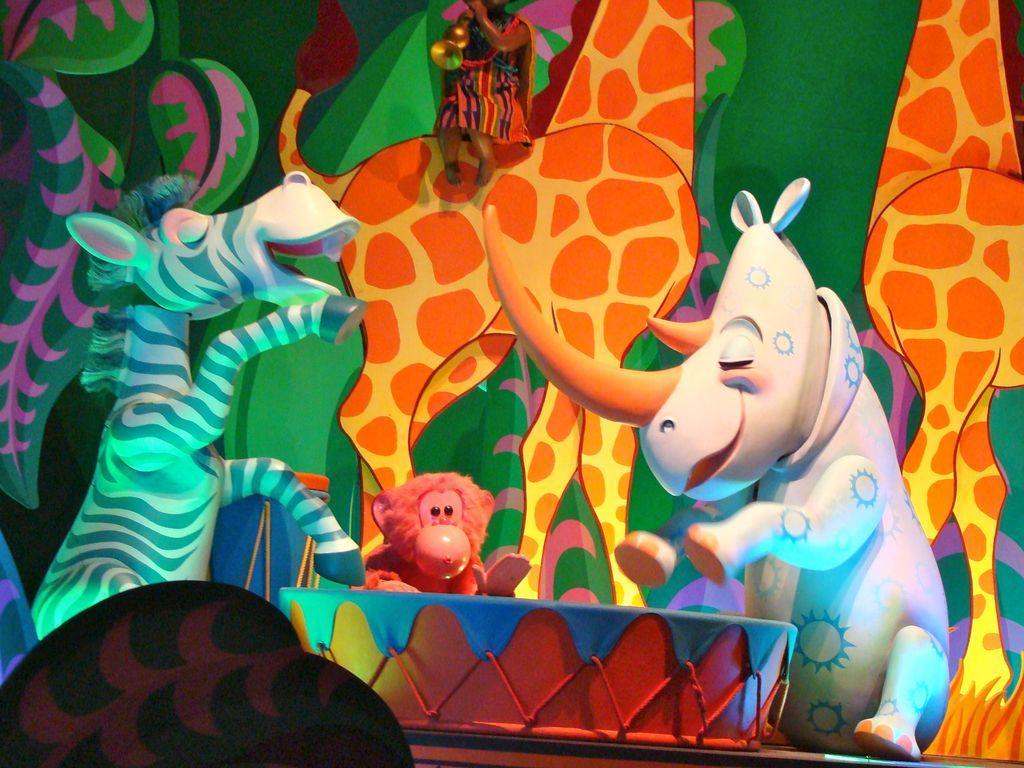Please provide a concise description of this image. In the image we can see there are cartoon statues of animals standing on the stage. There is a statue of zebra, hippopotamus, monkey and giraffe. There is a drum kept on the stage. 